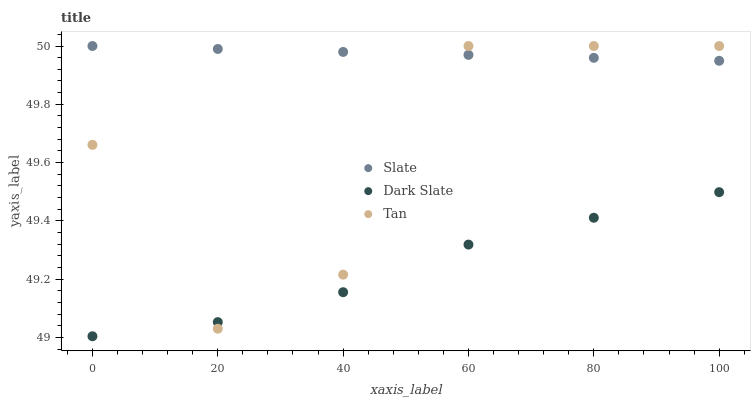Does Dark Slate have the minimum area under the curve?
Answer yes or no. Yes. Does Slate have the maximum area under the curve?
Answer yes or no. Yes. Does Tan have the minimum area under the curve?
Answer yes or no. No. Does Tan have the maximum area under the curve?
Answer yes or no. No. Is Slate the smoothest?
Answer yes or no. Yes. Is Tan the roughest?
Answer yes or no. Yes. Is Tan the smoothest?
Answer yes or no. No. Is Slate the roughest?
Answer yes or no. No. Does Dark Slate have the lowest value?
Answer yes or no. Yes. Does Tan have the lowest value?
Answer yes or no. No. Does Tan have the highest value?
Answer yes or no. Yes. Is Dark Slate less than Slate?
Answer yes or no. Yes. Is Slate greater than Dark Slate?
Answer yes or no. Yes. Does Slate intersect Tan?
Answer yes or no. Yes. Is Slate less than Tan?
Answer yes or no. No. Is Slate greater than Tan?
Answer yes or no. No. Does Dark Slate intersect Slate?
Answer yes or no. No. 